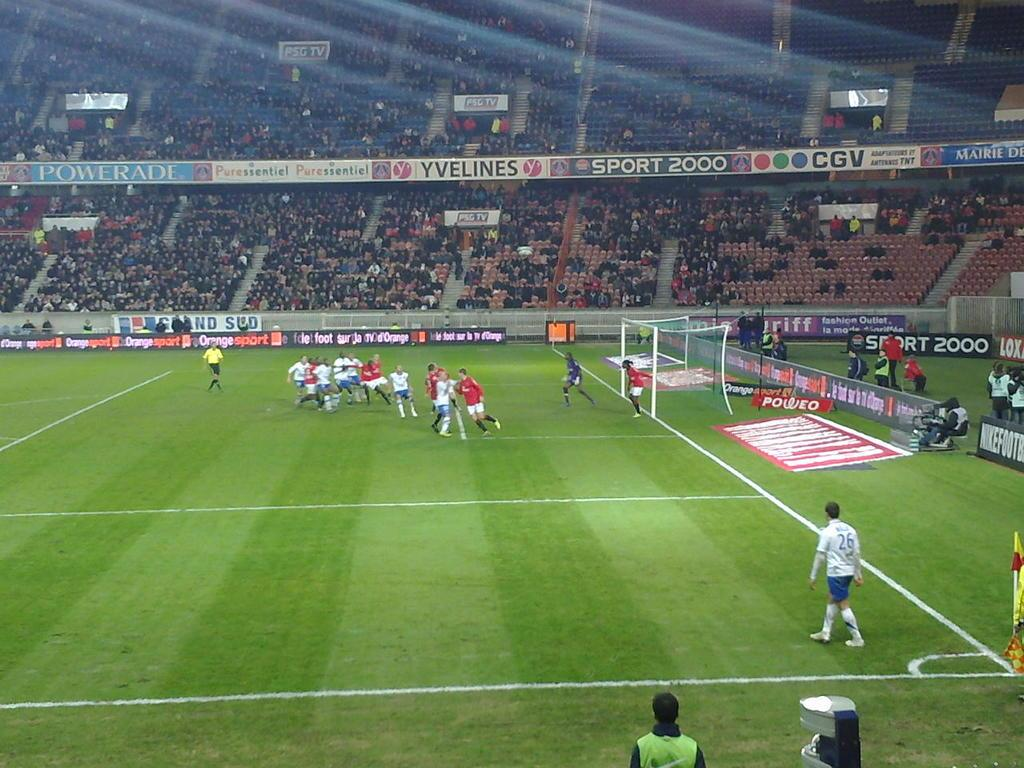<image>
Present a compact description of the photo's key features. A soccer player leaving the corner kick area on a soccer field in the Sport 2000 league. 